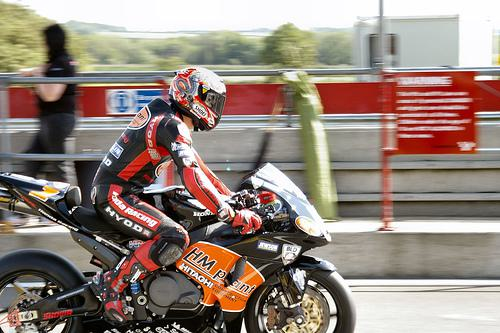Describe the safety gear the rider is wearing. The rider is equipped with essential safety gear for high-speed racing. This includes a full-body leather racing suit, which likely has reinforced padding or armor in critical areas, racing boots, gloves for grip and protection, and a full-face helmet that is crucial for head protection in the event of a crash. What precautions do racetracks take for rider safety? Racetracks are designed with rider safety as a priority. They include features like runoff areas that allow riders to decelerate safely in case of a mishap, impact-absorbing barriers, and sometimes air fence technology. The tracks have medical personnel on standby, and strict safety protocols are followed during events to protect the riders as much as possible. 